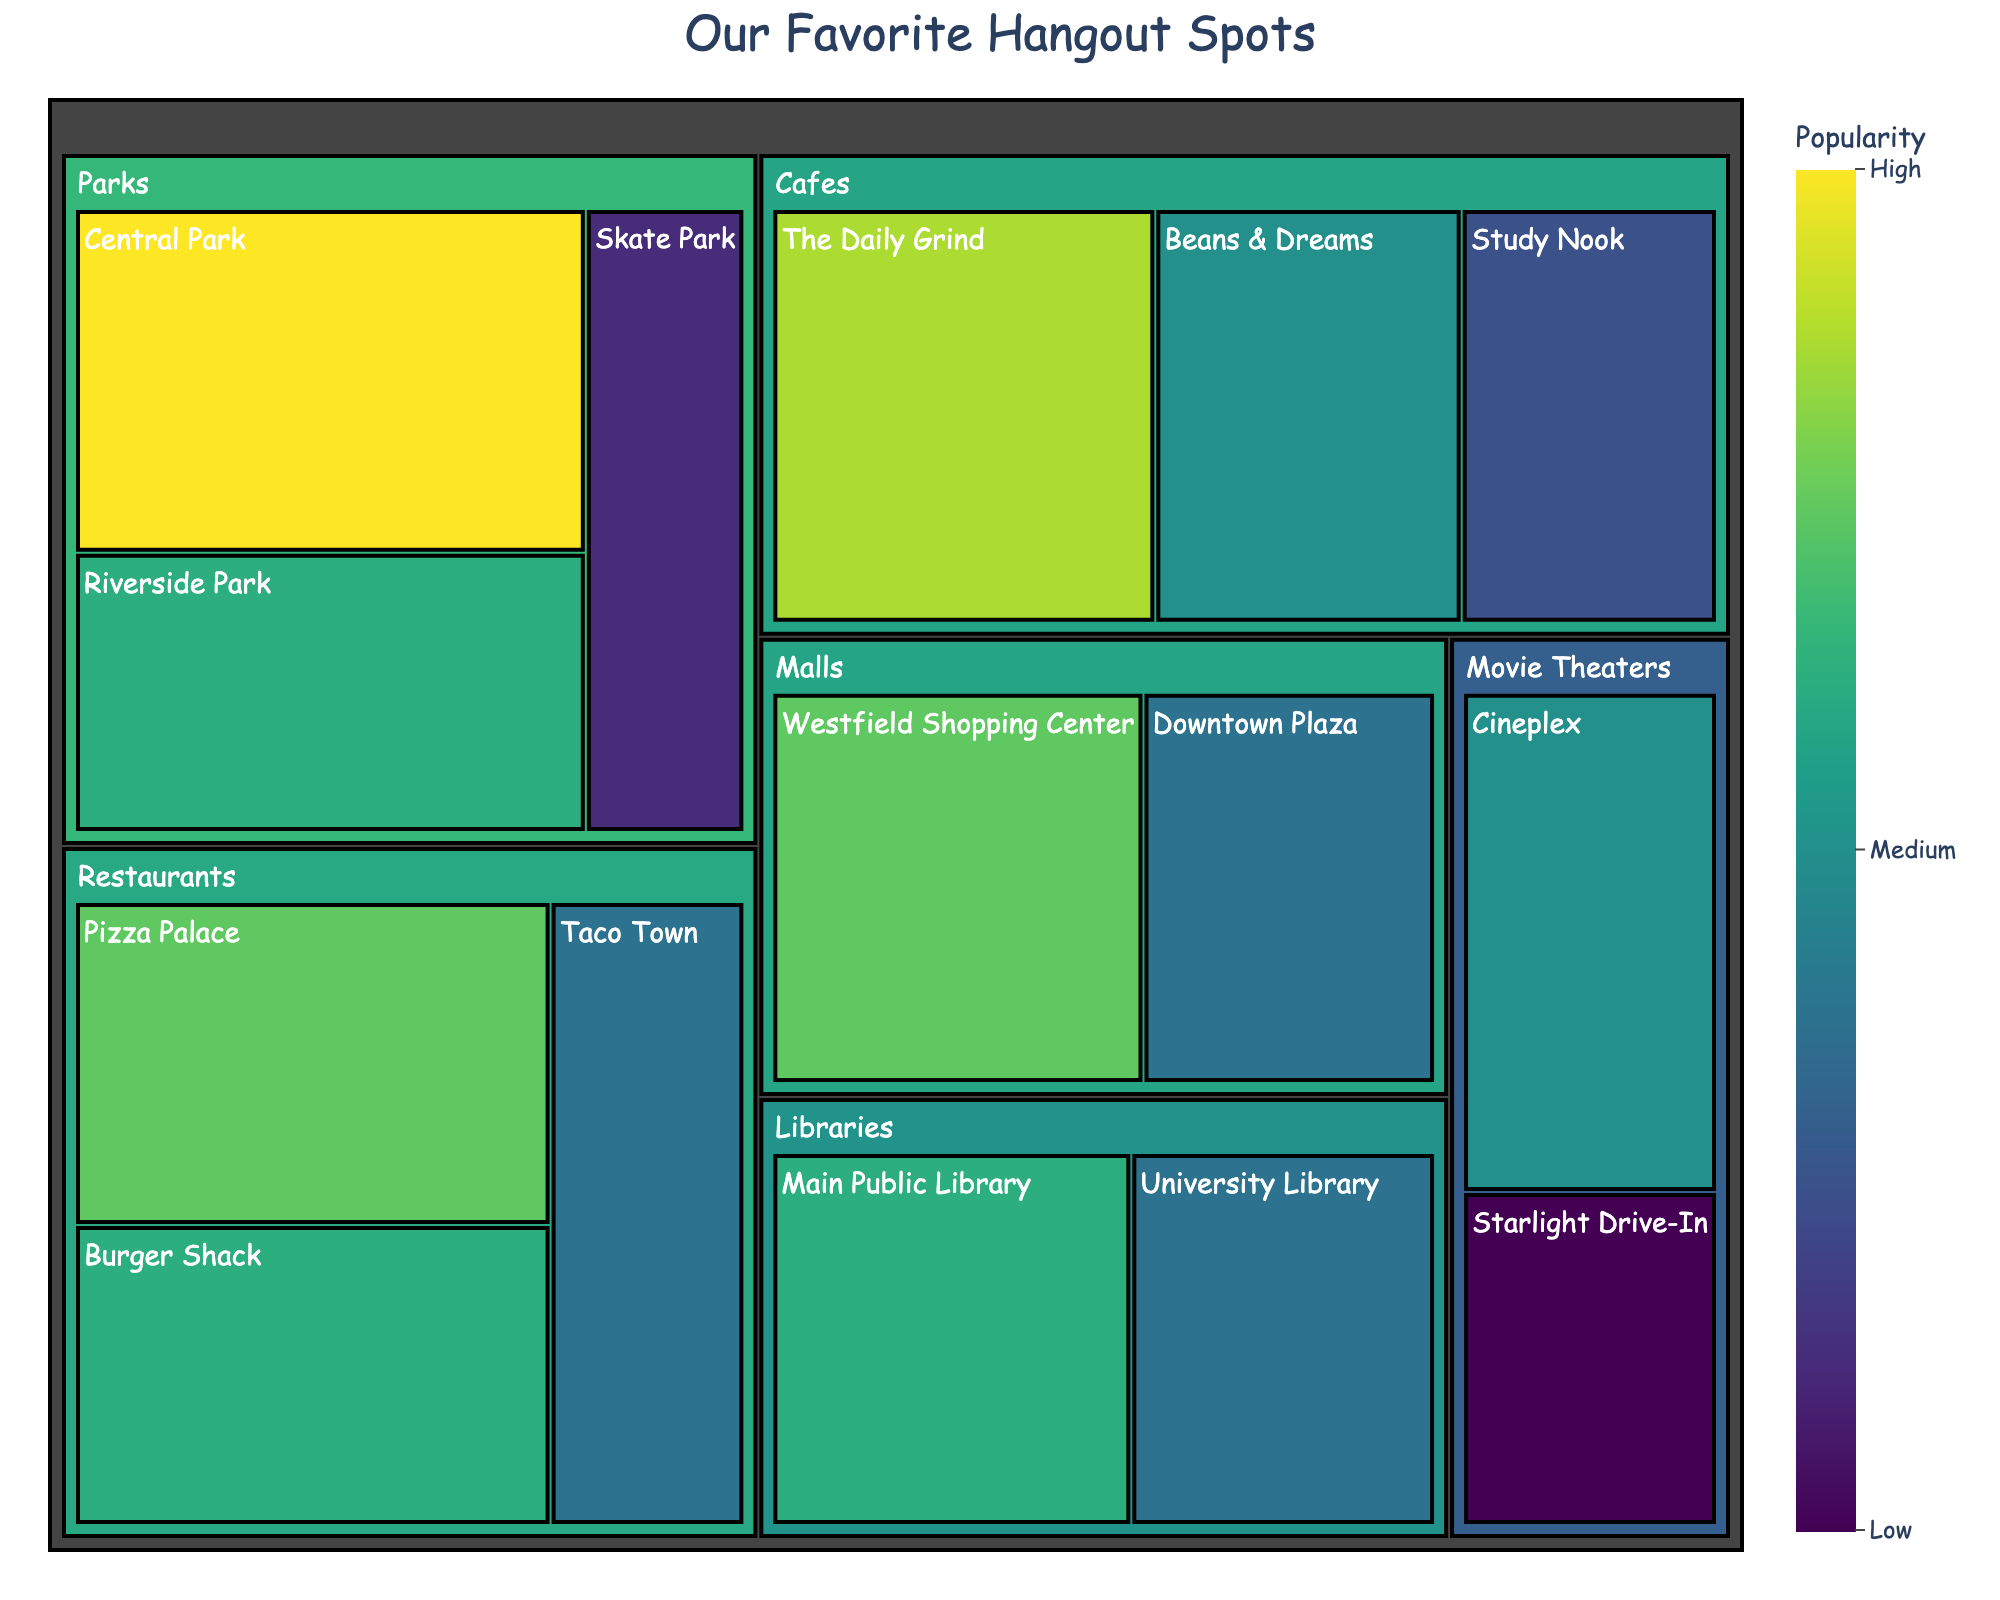What is the title of the figure? The title is displayed prominently at the top of the treemap. It summarizes the information represented in the plot.
Answer: Our Favorite Hangout Spots Which spot has the highest popularity? Central Park has the highest popularity score in the treemap, marked with the highest value of 80.
Answer: Central Park What categories are included in the figure? The treemap uses different colors and labels to show categories. Categories include Parks, Cafes, Malls, Libraries, Movie Theaters, and Restaurants.
Answer: Parks, Cafes, Malls, Libraries, Movie Theaters, Restaurants How many subcategories are there in the 'Parks' category? Under the 'Parks' category, there are three subcategories: Central Park, Riverside Park, and Skate Park.
Answer: 3 Which subcategory in 'Cafes' has the lowest popularity? The subcategory under 'Cafes' with the lowest popularity is Study Nook, as indicated by the value of 50.
Answer: Study Nook What is the total popularity of all the 'Libraries'? Combine the popularity values of Main Public Library (65) and University Library (55): 65 + 55 = 120.
Answer: 120 Which is more popular, 'Malls' or 'Movie Theaters'? Compare the total popularity values. 'Malls' have Westfield Shopping Center (70) and Downtown Plaza (55), total 125. 'Movie Theaters' have Cineplex (60) and Starlight Drive-In (40), total 100. 125 > 100, so 'Malls' are more popular.
Answer: Malls What is the average popularity of the 'Restaurants' subcategories? Combine the popularity of Pizza Palace (70), Burger Shack (65), and Taco Town (55): 70 + 65 + 55 = 190. Divide by 3: 190/3 ≈ 63.33.
Answer: 63.33 Which subcategory under 'Malls' has higher popularity? Compare the 'Malls' subcategories Westfield Shopping Center (70) and Downtown Plaza (55). Westfield Shopping Center has higher popularity.
Answer: Westfield Shopping Center List the subcategories in descending order of popularity. Arrange the subcategories by their popularity score from highest to lowest: Central Park (80), The Daily Grind (75), Westfield Shopping Center (70), Pizza Palace (70), Burger Shack (65), Main Public Library (65), Riverside Park (65), Beans & Dreams (60), Cineplex (60), Study Nook (50), Downtown Plaza (55), University Library (55), Taco Town (55), Skate Park (45), Starlight Drive-In (40).
Answer: Central Park, The Daily Grind, Westfield Shopping Center, Pizza Palace, Burger Shack, Main Public Library, Riverside Park, Beans & Dreams, Cineplex, Study Nook, Downtown Plaza, University Library, Taco Town, Skate Park, Starlight Drive-In 